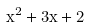Convert formula to latex. <formula><loc_0><loc_0><loc_500><loc_500>x ^ { 2 } + 3 x + 2</formula> 